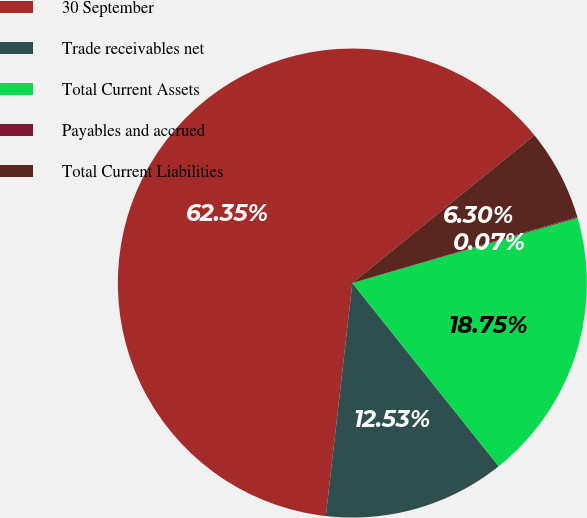Convert chart. <chart><loc_0><loc_0><loc_500><loc_500><pie_chart><fcel>30 September<fcel>Trade receivables net<fcel>Total Current Assets<fcel>Payables and accrued<fcel>Total Current Liabilities<nl><fcel>62.34%<fcel>12.53%<fcel>18.75%<fcel>0.07%<fcel>6.3%<nl></chart> 